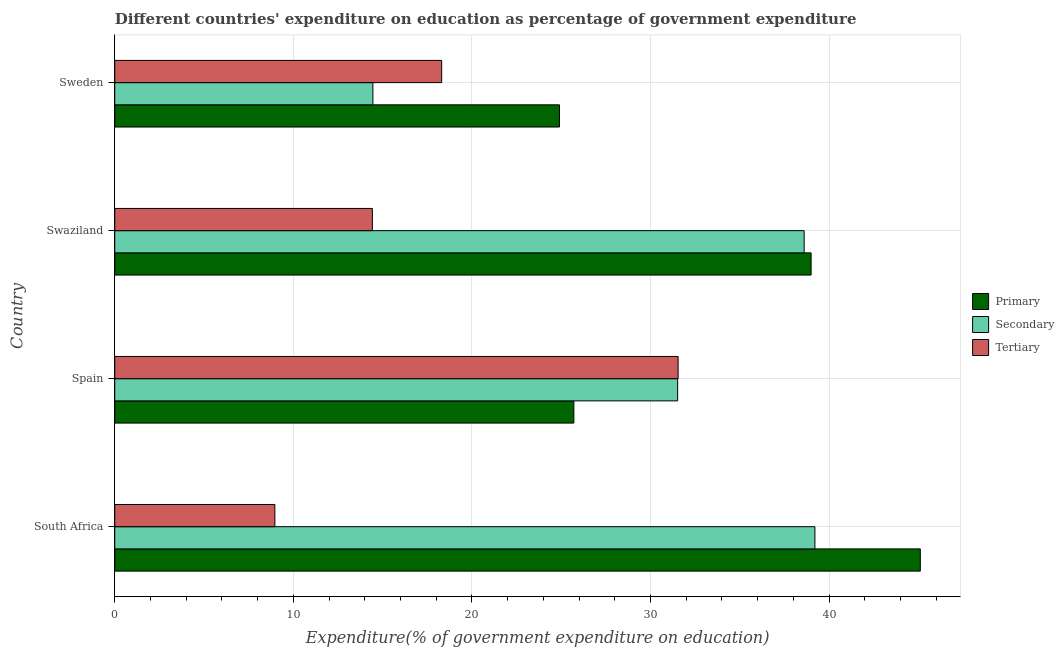Are the number of bars on each tick of the Y-axis equal?
Provide a short and direct response. Yes. How many bars are there on the 1st tick from the top?
Offer a very short reply. 3. What is the label of the 2nd group of bars from the top?
Make the answer very short. Swaziland. What is the expenditure on secondary education in Swaziland?
Keep it short and to the point. 38.6. Across all countries, what is the maximum expenditure on tertiary education?
Your response must be concise. 31.55. Across all countries, what is the minimum expenditure on primary education?
Your response must be concise. 24.9. In which country was the expenditure on secondary education maximum?
Keep it short and to the point. South Africa. In which country was the expenditure on tertiary education minimum?
Keep it short and to the point. South Africa. What is the total expenditure on secondary education in the graph?
Ensure brevity in your answer.  123.78. What is the difference between the expenditure on primary education in South Africa and that in Spain?
Your response must be concise. 19.4. What is the difference between the expenditure on secondary education in South Africa and the expenditure on tertiary education in Swaziland?
Make the answer very short. 24.78. What is the average expenditure on primary education per country?
Provide a succinct answer. 33.68. What is the difference between the expenditure on tertiary education and expenditure on secondary education in Swaziland?
Keep it short and to the point. -24.18. What is the ratio of the expenditure on tertiary education in Spain to that in Swaziland?
Make the answer very short. 2.19. Is the difference between the expenditure on primary education in Spain and Sweden greater than the difference between the expenditure on secondary education in Spain and Sweden?
Provide a succinct answer. No. What is the difference between the highest and the second highest expenditure on tertiary education?
Give a very brief answer. 13.24. What is the difference between the highest and the lowest expenditure on primary education?
Offer a terse response. 20.2. In how many countries, is the expenditure on tertiary education greater than the average expenditure on tertiary education taken over all countries?
Provide a short and direct response. 1. Is the sum of the expenditure on tertiary education in South Africa and Swaziland greater than the maximum expenditure on secondary education across all countries?
Offer a very short reply. No. What does the 2nd bar from the top in Spain represents?
Provide a short and direct response. Secondary. What does the 3rd bar from the bottom in Sweden represents?
Provide a short and direct response. Tertiary. Is it the case that in every country, the sum of the expenditure on primary education and expenditure on secondary education is greater than the expenditure on tertiary education?
Offer a very short reply. Yes. How many bars are there?
Offer a very short reply. 12. How many countries are there in the graph?
Keep it short and to the point. 4. Are the values on the major ticks of X-axis written in scientific E-notation?
Ensure brevity in your answer.  No. Does the graph contain any zero values?
Offer a terse response. No. How are the legend labels stacked?
Provide a short and direct response. Vertical. What is the title of the graph?
Your answer should be very brief. Different countries' expenditure on education as percentage of government expenditure. What is the label or title of the X-axis?
Give a very brief answer. Expenditure(% of government expenditure on education). What is the label or title of the Y-axis?
Your answer should be compact. Country. What is the Expenditure(% of government expenditure on education) in Primary in South Africa?
Provide a short and direct response. 45.11. What is the Expenditure(% of government expenditure on education) in Secondary in South Africa?
Ensure brevity in your answer.  39.2. What is the Expenditure(% of government expenditure on education) of Tertiary in South Africa?
Offer a very short reply. 8.97. What is the Expenditure(% of government expenditure on education) of Primary in Spain?
Give a very brief answer. 25.71. What is the Expenditure(% of government expenditure on education) of Secondary in Spain?
Keep it short and to the point. 31.52. What is the Expenditure(% of government expenditure on education) in Tertiary in Spain?
Keep it short and to the point. 31.55. What is the Expenditure(% of government expenditure on education) of Primary in Swaziland?
Keep it short and to the point. 38.99. What is the Expenditure(% of government expenditure on education) in Secondary in Swaziland?
Your answer should be compact. 38.6. What is the Expenditure(% of government expenditure on education) in Tertiary in Swaziland?
Provide a short and direct response. 14.43. What is the Expenditure(% of government expenditure on education) in Primary in Sweden?
Ensure brevity in your answer.  24.9. What is the Expenditure(% of government expenditure on education) in Secondary in Sweden?
Provide a short and direct response. 14.45. What is the Expenditure(% of government expenditure on education) in Tertiary in Sweden?
Your response must be concise. 18.31. Across all countries, what is the maximum Expenditure(% of government expenditure on education) in Primary?
Keep it short and to the point. 45.11. Across all countries, what is the maximum Expenditure(% of government expenditure on education) of Secondary?
Ensure brevity in your answer.  39.2. Across all countries, what is the maximum Expenditure(% of government expenditure on education) of Tertiary?
Your response must be concise. 31.55. Across all countries, what is the minimum Expenditure(% of government expenditure on education) of Primary?
Provide a short and direct response. 24.9. Across all countries, what is the minimum Expenditure(% of government expenditure on education) in Secondary?
Ensure brevity in your answer.  14.45. Across all countries, what is the minimum Expenditure(% of government expenditure on education) of Tertiary?
Your answer should be compact. 8.97. What is the total Expenditure(% of government expenditure on education) of Primary in the graph?
Offer a terse response. 134.71. What is the total Expenditure(% of government expenditure on education) of Secondary in the graph?
Ensure brevity in your answer.  123.78. What is the total Expenditure(% of government expenditure on education) of Tertiary in the graph?
Your answer should be compact. 73.24. What is the difference between the Expenditure(% of government expenditure on education) in Primary in South Africa and that in Spain?
Offer a very short reply. 19.4. What is the difference between the Expenditure(% of government expenditure on education) in Secondary in South Africa and that in Spain?
Your answer should be very brief. 7.68. What is the difference between the Expenditure(% of government expenditure on education) of Tertiary in South Africa and that in Spain?
Your response must be concise. -22.58. What is the difference between the Expenditure(% of government expenditure on education) of Primary in South Africa and that in Swaziland?
Offer a very short reply. 6.11. What is the difference between the Expenditure(% of government expenditure on education) of Secondary in South Africa and that in Swaziland?
Provide a succinct answer. 0.6. What is the difference between the Expenditure(% of government expenditure on education) in Tertiary in South Africa and that in Swaziland?
Provide a succinct answer. -5.46. What is the difference between the Expenditure(% of government expenditure on education) in Primary in South Africa and that in Sweden?
Keep it short and to the point. 20.2. What is the difference between the Expenditure(% of government expenditure on education) in Secondary in South Africa and that in Sweden?
Provide a short and direct response. 24.75. What is the difference between the Expenditure(% of government expenditure on education) of Tertiary in South Africa and that in Sweden?
Provide a succinct answer. -9.34. What is the difference between the Expenditure(% of government expenditure on education) in Primary in Spain and that in Swaziland?
Offer a very short reply. -13.28. What is the difference between the Expenditure(% of government expenditure on education) in Secondary in Spain and that in Swaziland?
Offer a terse response. -7.08. What is the difference between the Expenditure(% of government expenditure on education) in Tertiary in Spain and that in Swaziland?
Offer a very short reply. 17.12. What is the difference between the Expenditure(% of government expenditure on education) in Primary in Spain and that in Sweden?
Give a very brief answer. 0.81. What is the difference between the Expenditure(% of government expenditure on education) in Secondary in Spain and that in Sweden?
Your response must be concise. 17.07. What is the difference between the Expenditure(% of government expenditure on education) of Tertiary in Spain and that in Sweden?
Provide a short and direct response. 13.24. What is the difference between the Expenditure(% of government expenditure on education) of Primary in Swaziland and that in Sweden?
Provide a succinct answer. 14.09. What is the difference between the Expenditure(% of government expenditure on education) in Secondary in Swaziland and that in Sweden?
Keep it short and to the point. 24.15. What is the difference between the Expenditure(% of government expenditure on education) of Tertiary in Swaziland and that in Sweden?
Offer a terse response. -3.88. What is the difference between the Expenditure(% of government expenditure on education) of Primary in South Africa and the Expenditure(% of government expenditure on education) of Secondary in Spain?
Offer a terse response. 13.59. What is the difference between the Expenditure(% of government expenditure on education) in Primary in South Africa and the Expenditure(% of government expenditure on education) in Tertiary in Spain?
Give a very brief answer. 13.56. What is the difference between the Expenditure(% of government expenditure on education) of Secondary in South Africa and the Expenditure(% of government expenditure on education) of Tertiary in Spain?
Make the answer very short. 7.66. What is the difference between the Expenditure(% of government expenditure on education) of Primary in South Africa and the Expenditure(% of government expenditure on education) of Secondary in Swaziland?
Your response must be concise. 6.5. What is the difference between the Expenditure(% of government expenditure on education) of Primary in South Africa and the Expenditure(% of government expenditure on education) of Tertiary in Swaziland?
Give a very brief answer. 30.68. What is the difference between the Expenditure(% of government expenditure on education) in Secondary in South Africa and the Expenditure(% of government expenditure on education) in Tertiary in Swaziland?
Provide a short and direct response. 24.78. What is the difference between the Expenditure(% of government expenditure on education) in Primary in South Africa and the Expenditure(% of government expenditure on education) in Secondary in Sweden?
Ensure brevity in your answer.  30.65. What is the difference between the Expenditure(% of government expenditure on education) of Primary in South Africa and the Expenditure(% of government expenditure on education) of Tertiary in Sweden?
Keep it short and to the point. 26.8. What is the difference between the Expenditure(% of government expenditure on education) in Secondary in South Africa and the Expenditure(% of government expenditure on education) in Tertiary in Sweden?
Your answer should be very brief. 20.9. What is the difference between the Expenditure(% of government expenditure on education) in Primary in Spain and the Expenditure(% of government expenditure on education) in Secondary in Swaziland?
Your answer should be compact. -12.9. What is the difference between the Expenditure(% of government expenditure on education) in Primary in Spain and the Expenditure(% of government expenditure on education) in Tertiary in Swaziland?
Keep it short and to the point. 11.28. What is the difference between the Expenditure(% of government expenditure on education) in Secondary in Spain and the Expenditure(% of government expenditure on education) in Tertiary in Swaziland?
Offer a very short reply. 17.09. What is the difference between the Expenditure(% of government expenditure on education) of Primary in Spain and the Expenditure(% of government expenditure on education) of Secondary in Sweden?
Offer a terse response. 11.25. What is the difference between the Expenditure(% of government expenditure on education) in Primary in Spain and the Expenditure(% of government expenditure on education) in Tertiary in Sweden?
Provide a short and direct response. 7.4. What is the difference between the Expenditure(% of government expenditure on education) in Secondary in Spain and the Expenditure(% of government expenditure on education) in Tertiary in Sweden?
Provide a succinct answer. 13.21. What is the difference between the Expenditure(% of government expenditure on education) of Primary in Swaziland and the Expenditure(% of government expenditure on education) of Secondary in Sweden?
Your response must be concise. 24.54. What is the difference between the Expenditure(% of government expenditure on education) in Primary in Swaziland and the Expenditure(% of government expenditure on education) in Tertiary in Sweden?
Make the answer very short. 20.69. What is the difference between the Expenditure(% of government expenditure on education) in Secondary in Swaziland and the Expenditure(% of government expenditure on education) in Tertiary in Sweden?
Your response must be concise. 20.3. What is the average Expenditure(% of government expenditure on education) of Primary per country?
Provide a short and direct response. 33.68. What is the average Expenditure(% of government expenditure on education) of Secondary per country?
Your answer should be very brief. 30.94. What is the average Expenditure(% of government expenditure on education) of Tertiary per country?
Your answer should be compact. 18.31. What is the difference between the Expenditure(% of government expenditure on education) of Primary and Expenditure(% of government expenditure on education) of Secondary in South Africa?
Your answer should be very brief. 5.9. What is the difference between the Expenditure(% of government expenditure on education) of Primary and Expenditure(% of government expenditure on education) of Tertiary in South Africa?
Your answer should be compact. 36.14. What is the difference between the Expenditure(% of government expenditure on education) in Secondary and Expenditure(% of government expenditure on education) in Tertiary in South Africa?
Ensure brevity in your answer.  30.24. What is the difference between the Expenditure(% of government expenditure on education) in Primary and Expenditure(% of government expenditure on education) in Secondary in Spain?
Ensure brevity in your answer.  -5.81. What is the difference between the Expenditure(% of government expenditure on education) in Primary and Expenditure(% of government expenditure on education) in Tertiary in Spain?
Give a very brief answer. -5.84. What is the difference between the Expenditure(% of government expenditure on education) in Secondary and Expenditure(% of government expenditure on education) in Tertiary in Spain?
Make the answer very short. -0.03. What is the difference between the Expenditure(% of government expenditure on education) of Primary and Expenditure(% of government expenditure on education) of Secondary in Swaziland?
Offer a very short reply. 0.39. What is the difference between the Expenditure(% of government expenditure on education) of Primary and Expenditure(% of government expenditure on education) of Tertiary in Swaziland?
Provide a succinct answer. 24.57. What is the difference between the Expenditure(% of government expenditure on education) of Secondary and Expenditure(% of government expenditure on education) of Tertiary in Swaziland?
Provide a succinct answer. 24.18. What is the difference between the Expenditure(% of government expenditure on education) in Primary and Expenditure(% of government expenditure on education) in Secondary in Sweden?
Give a very brief answer. 10.45. What is the difference between the Expenditure(% of government expenditure on education) in Primary and Expenditure(% of government expenditure on education) in Tertiary in Sweden?
Keep it short and to the point. 6.6. What is the difference between the Expenditure(% of government expenditure on education) of Secondary and Expenditure(% of government expenditure on education) of Tertiary in Sweden?
Your answer should be compact. -3.85. What is the ratio of the Expenditure(% of government expenditure on education) of Primary in South Africa to that in Spain?
Your answer should be very brief. 1.75. What is the ratio of the Expenditure(% of government expenditure on education) of Secondary in South Africa to that in Spain?
Your answer should be compact. 1.24. What is the ratio of the Expenditure(% of government expenditure on education) of Tertiary in South Africa to that in Spain?
Make the answer very short. 0.28. What is the ratio of the Expenditure(% of government expenditure on education) in Primary in South Africa to that in Swaziland?
Ensure brevity in your answer.  1.16. What is the ratio of the Expenditure(% of government expenditure on education) in Secondary in South Africa to that in Swaziland?
Offer a terse response. 1.02. What is the ratio of the Expenditure(% of government expenditure on education) in Tertiary in South Africa to that in Swaziland?
Offer a very short reply. 0.62. What is the ratio of the Expenditure(% of government expenditure on education) in Primary in South Africa to that in Sweden?
Offer a terse response. 1.81. What is the ratio of the Expenditure(% of government expenditure on education) of Secondary in South Africa to that in Sweden?
Give a very brief answer. 2.71. What is the ratio of the Expenditure(% of government expenditure on education) of Tertiary in South Africa to that in Sweden?
Provide a short and direct response. 0.49. What is the ratio of the Expenditure(% of government expenditure on education) in Primary in Spain to that in Swaziland?
Provide a short and direct response. 0.66. What is the ratio of the Expenditure(% of government expenditure on education) of Secondary in Spain to that in Swaziland?
Offer a terse response. 0.82. What is the ratio of the Expenditure(% of government expenditure on education) in Tertiary in Spain to that in Swaziland?
Your response must be concise. 2.19. What is the ratio of the Expenditure(% of government expenditure on education) of Primary in Spain to that in Sweden?
Your answer should be compact. 1.03. What is the ratio of the Expenditure(% of government expenditure on education) in Secondary in Spain to that in Sweden?
Give a very brief answer. 2.18. What is the ratio of the Expenditure(% of government expenditure on education) in Tertiary in Spain to that in Sweden?
Your answer should be compact. 1.72. What is the ratio of the Expenditure(% of government expenditure on education) of Primary in Swaziland to that in Sweden?
Your response must be concise. 1.57. What is the ratio of the Expenditure(% of government expenditure on education) in Secondary in Swaziland to that in Sweden?
Provide a short and direct response. 2.67. What is the ratio of the Expenditure(% of government expenditure on education) of Tertiary in Swaziland to that in Sweden?
Offer a very short reply. 0.79. What is the difference between the highest and the second highest Expenditure(% of government expenditure on education) of Primary?
Offer a very short reply. 6.11. What is the difference between the highest and the second highest Expenditure(% of government expenditure on education) of Secondary?
Keep it short and to the point. 0.6. What is the difference between the highest and the second highest Expenditure(% of government expenditure on education) in Tertiary?
Your answer should be compact. 13.24. What is the difference between the highest and the lowest Expenditure(% of government expenditure on education) in Primary?
Keep it short and to the point. 20.2. What is the difference between the highest and the lowest Expenditure(% of government expenditure on education) of Secondary?
Offer a terse response. 24.75. What is the difference between the highest and the lowest Expenditure(% of government expenditure on education) in Tertiary?
Ensure brevity in your answer.  22.58. 